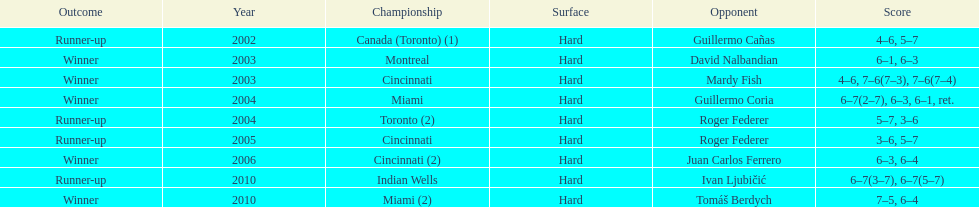In how many events was roger federer the runner-up? 2. 